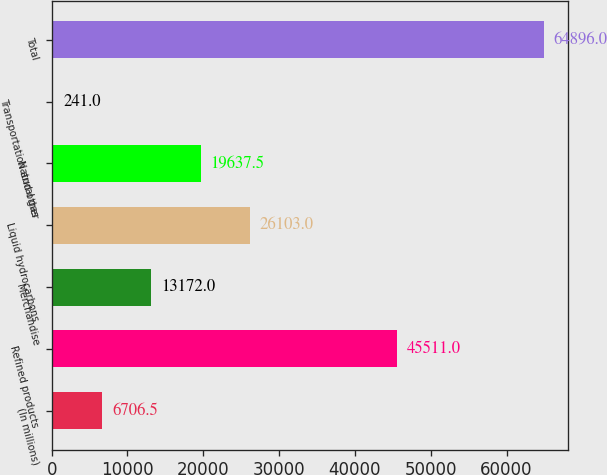Convert chart. <chart><loc_0><loc_0><loc_500><loc_500><bar_chart><fcel>(In millions)<fcel>Refined products<fcel>Merchandise<fcel>Liquid hydrocarbons<fcel>Natural gas<fcel>Transportation and other<fcel>Total<nl><fcel>6706.5<fcel>45511<fcel>13172<fcel>26103<fcel>19637.5<fcel>241<fcel>64896<nl></chart> 